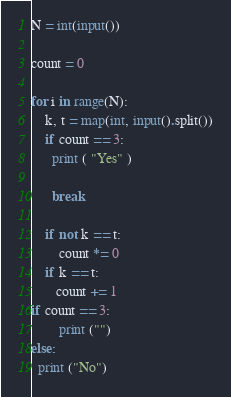Convert code to text. <code><loc_0><loc_0><loc_500><loc_500><_Python_>N = int(input())

count = 0

for i in range(N):
    k, t = map(int, input().split())
    if count == 3:
      print ( "Yes" )
     
      break
      
    if not k == t:
        count *= 0
    if k == t:
       count += 1 
if count == 3:
        print ("")
else:
  print ("No")

</code> 